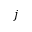<formula> <loc_0><loc_0><loc_500><loc_500>j</formula> 